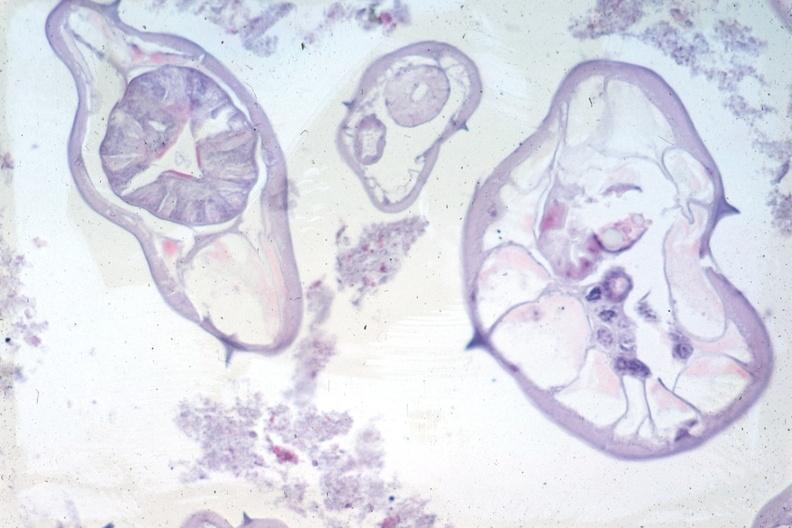s pinworm present?
Answer the question using a single word or phrase. Yes 